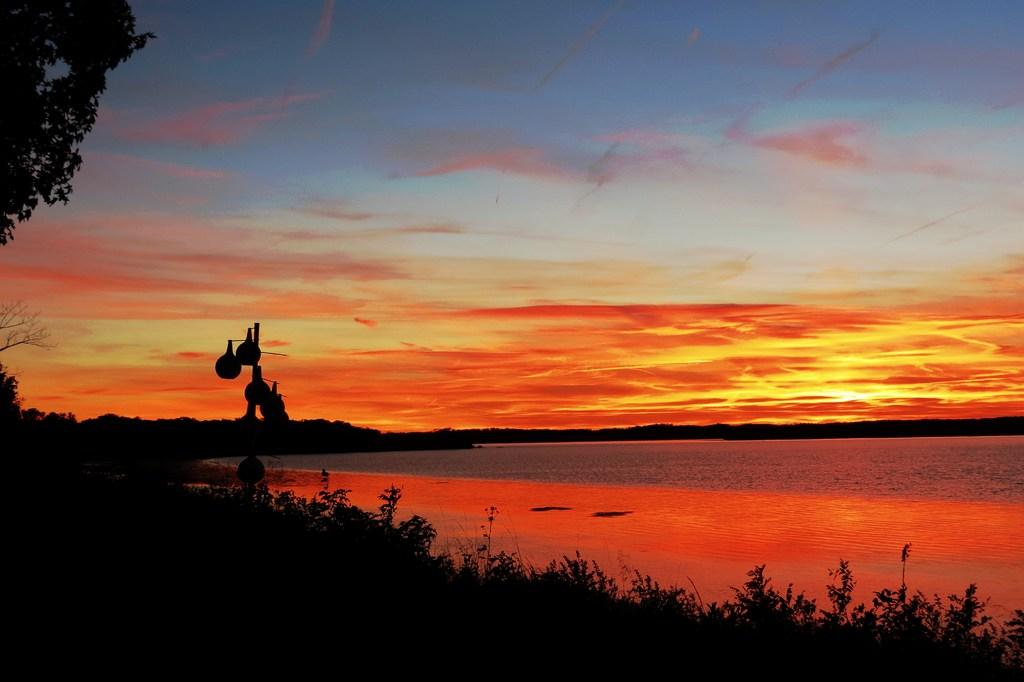What type of vegetation is at the bottom of the image? There are plants at the bottom of the image. What can be seen on the left side of the image? There is a tree on the left side of the image. What is visible in the middle of the image? There is water visible in the middle of the image. What is visible at the top of the image? The sky is visible at the top of the image. What can be observed in the sky? Clouds are present in the sky. What is the tendency of the office to affect the plants in the image? There is no office present in the image, so it is not possible to determine any tendency affecting the plants. 